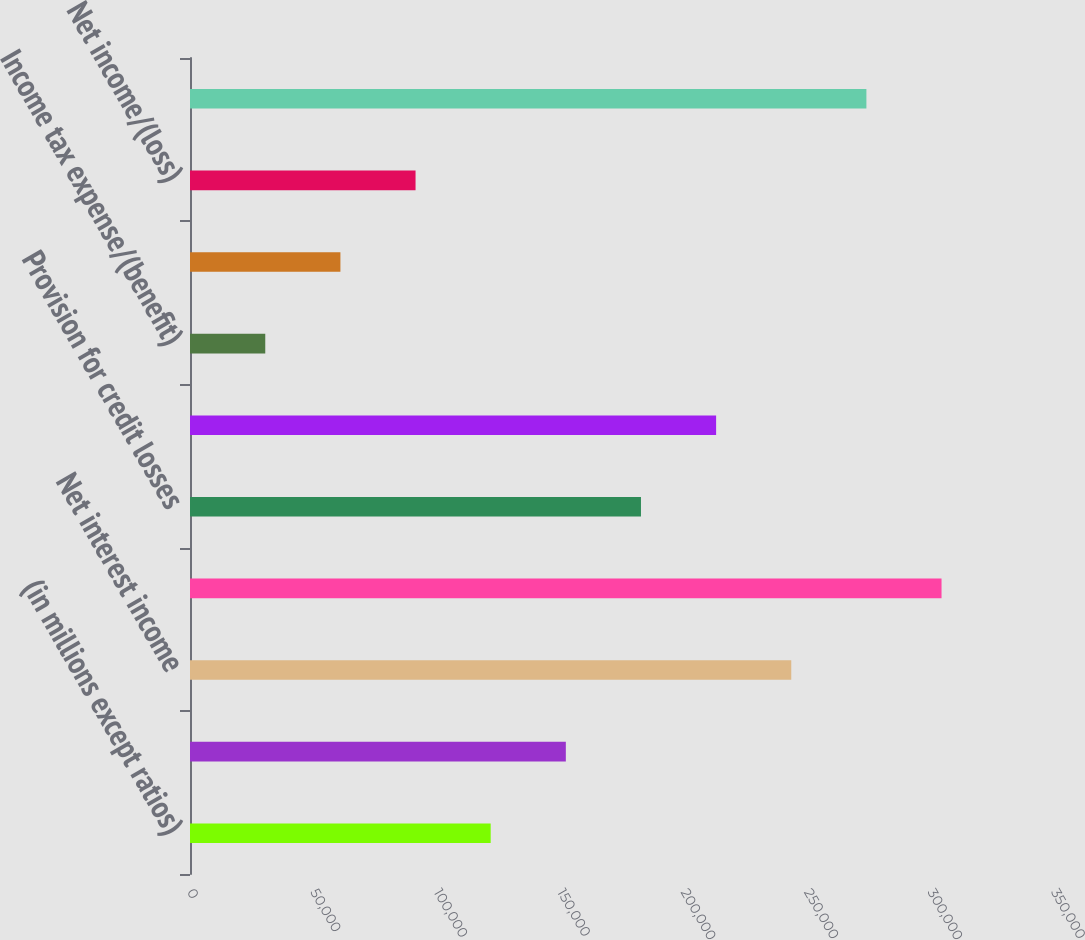Convert chart to OTSL. <chart><loc_0><loc_0><loc_500><loc_500><bar_chart><fcel>(in millions except ratios)<fcel>Noninterest revenue<fcel>Net interest income<fcel>Total net revenue<fcel>Provision for credit losses<fcel>Noninterest expense (c)<fcel>Income tax expense/(benefit)<fcel>Income/(loss) before<fcel>Net income/(loss)<fcel>Average common equity<nl><fcel>121807<fcel>152246<fcel>243564<fcel>304442<fcel>182686<fcel>213125<fcel>30490.1<fcel>60929.2<fcel>91368.3<fcel>274003<nl></chart> 